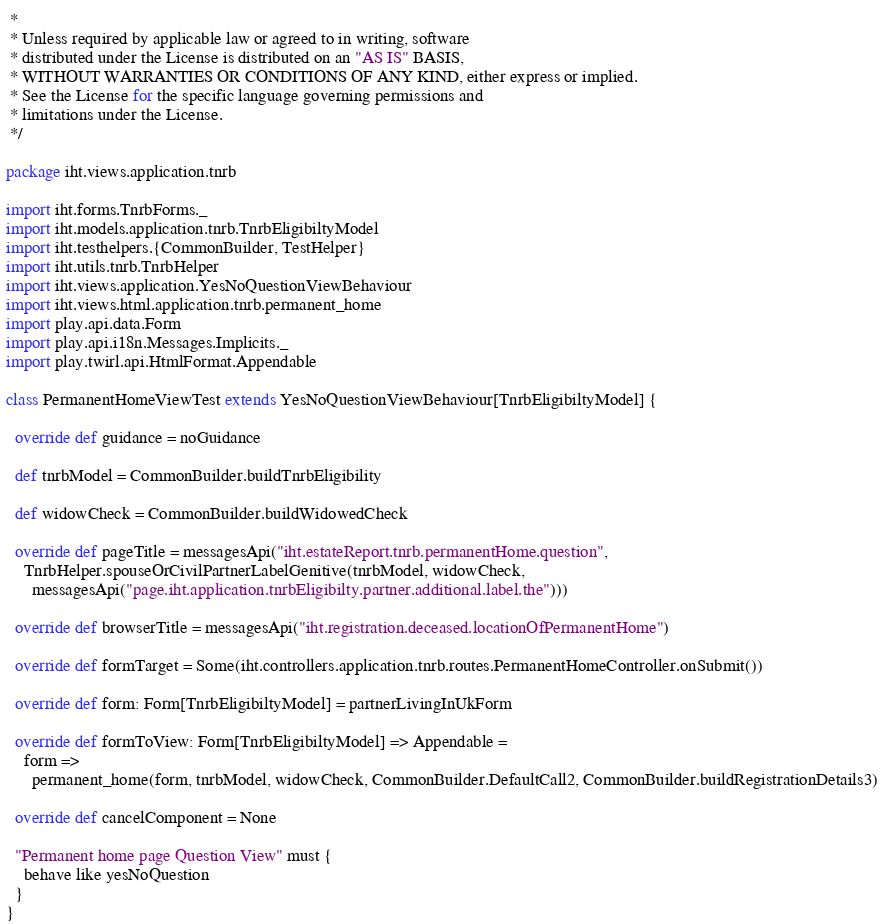<code> <loc_0><loc_0><loc_500><loc_500><_Scala_> *
 * Unless required by applicable law or agreed to in writing, software
 * distributed under the License is distributed on an "AS IS" BASIS,
 * WITHOUT WARRANTIES OR CONDITIONS OF ANY KIND, either express or implied.
 * See the License for the specific language governing permissions and
 * limitations under the License.
 */

package iht.views.application.tnrb

import iht.forms.TnrbForms._
import iht.models.application.tnrb.TnrbEligibiltyModel
import iht.testhelpers.{CommonBuilder, TestHelper}
import iht.utils.tnrb.TnrbHelper
import iht.views.application.YesNoQuestionViewBehaviour
import iht.views.html.application.tnrb.permanent_home
import play.api.data.Form
import play.api.i18n.Messages.Implicits._
import play.twirl.api.HtmlFormat.Appendable

class PermanentHomeViewTest extends YesNoQuestionViewBehaviour[TnrbEligibiltyModel] {

  override def guidance = noGuidance

  def tnrbModel = CommonBuilder.buildTnrbEligibility

  def widowCheck = CommonBuilder.buildWidowedCheck

  override def pageTitle = messagesApi("iht.estateReport.tnrb.permanentHome.question",
    TnrbHelper.spouseOrCivilPartnerLabelGenitive(tnrbModel, widowCheck,
      messagesApi("page.iht.application.tnrbEligibilty.partner.additional.label.the")))

  override def browserTitle = messagesApi("iht.registration.deceased.locationOfPermanentHome")

  override def formTarget = Some(iht.controllers.application.tnrb.routes.PermanentHomeController.onSubmit())

  override def form: Form[TnrbEligibiltyModel] = partnerLivingInUkForm

  override def formToView: Form[TnrbEligibiltyModel] => Appendable =
    form =>
      permanent_home(form, tnrbModel, widowCheck, CommonBuilder.DefaultCall2, CommonBuilder.buildRegistrationDetails3)

  override def cancelComponent = None

  "Permanent home page Question View" must {
    behave like yesNoQuestion
  }
}
</code> 